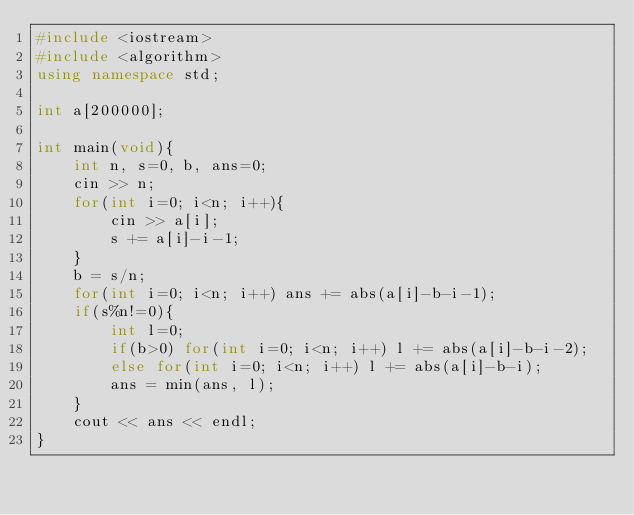<code> <loc_0><loc_0><loc_500><loc_500><_C++_>#include <iostream>
#include <algorithm>
using namespace std;

int a[200000];

int main(void){
	int n, s=0, b, ans=0;
	cin >> n;
	for(int i=0; i<n; i++){
		cin >> a[i];
		s += a[i]-i-1;
	}
	b = s/n;
	for(int i=0; i<n; i++) ans += abs(a[i]-b-i-1);
	if(s%n!=0){
		int l=0;
		if(b>0) for(int i=0; i<n; i++) l += abs(a[i]-b-i-2);
		else for(int i=0; i<n; i++) l += abs(a[i]-b-i);
		ans = min(ans, l);
	}
	cout << ans << endl;
}</code> 